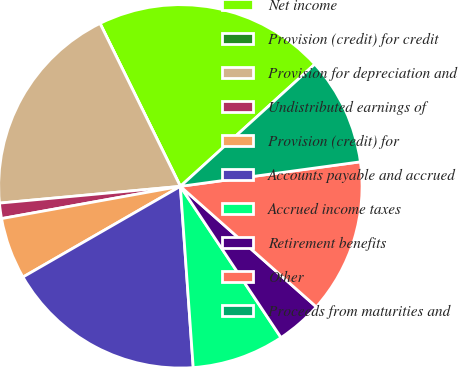Convert chart. <chart><loc_0><loc_0><loc_500><loc_500><pie_chart><fcel>Net income<fcel>Provision (credit) for credit<fcel>Provision for depreciation and<fcel>Undistributed earnings of<fcel>Provision (credit) for<fcel>Accounts payable and accrued<fcel>Accrued income taxes<fcel>Retirement benefits<fcel>Other<fcel>Proceeds from maturities and<nl><fcel>20.55%<fcel>0.0%<fcel>19.18%<fcel>1.37%<fcel>5.48%<fcel>17.81%<fcel>8.22%<fcel>4.11%<fcel>13.7%<fcel>9.59%<nl></chart> 